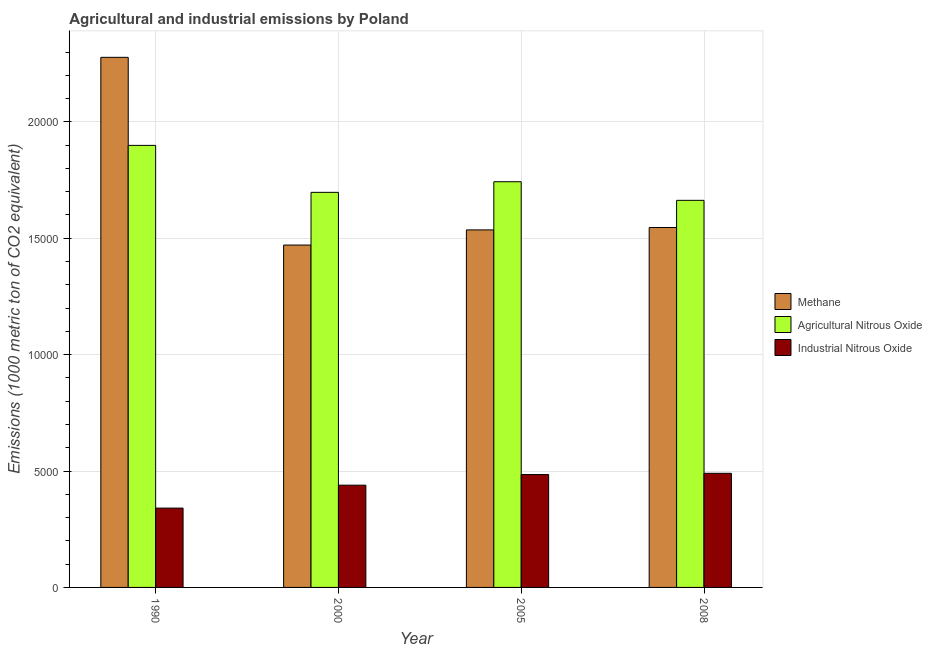How many different coloured bars are there?
Give a very brief answer. 3. How many groups of bars are there?
Your answer should be compact. 4. Are the number of bars on each tick of the X-axis equal?
Your answer should be very brief. Yes. How many bars are there on the 4th tick from the left?
Ensure brevity in your answer.  3. What is the amount of agricultural nitrous oxide emissions in 2008?
Offer a terse response. 1.66e+04. Across all years, what is the maximum amount of methane emissions?
Offer a terse response. 2.28e+04. Across all years, what is the minimum amount of industrial nitrous oxide emissions?
Provide a short and direct response. 3408.2. What is the total amount of agricultural nitrous oxide emissions in the graph?
Offer a very short reply. 7.00e+04. What is the difference between the amount of industrial nitrous oxide emissions in 1990 and that in 2005?
Provide a succinct answer. -1440.8. What is the difference between the amount of industrial nitrous oxide emissions in 2000 and the amount of methane emissions in 1990?
Your answer should be very brief. 984.3. What is the average amount of industrial nitrous oxide emissions per year?
Your response must be concise. 4388.1. In how many years, is the amount of industrial nitrous oxide emissions greater than 14000 metric ton?
Make the answer very short. 0. What is the ratio of the amount of industrial nitrous oxide emissions in 1990 to that in 2000?
Your response must be concise. 0.78. Is the amount of industrial nitrous oxide emissions in 2000 less than that in 2008?
Offer a very short reply. Yes. What is the difference between the highest and the second highest amount of industrial nitrous oxide emissions?
Offer a very short reply. 53.7. What is the difference between the highest and the lowest amount of industrial nitrous oxide emissions?
Your answer should be compact. 1494.5. Is the sum of the amount of industrial nitrous oxide emissions in 1990 and 2005 greater than the maximum amount of agricultural nitrous oxide emissions across all years?
Provide a short and direct response. Yes. What does the 3rd bar from the left in 2000 represents?
Provide a short and direct response. Industrial Nitrous Oxide. What does the 2nd bar from the right in 2000 represents?
Your response must be concise. Agricultural Nitrous Oxide. Is it the case that in every year, the sum of the amount of methane emissions and amount of agricultural nitrous oxide emissions is greater than the amount of industrial nitrous oxide emissions?
Your answer should be compact. Yes. How many bars are there?
Keep it short and to the point. 12. How many years are there in the graph?
Provide a succinct answer. 4. Are the values on the major ticks of Y-axis written in scientific E-notation?
Ensure brevity in your answer.  No. How many legend labels are there?
Keep it short and to the point. 3. What is the title of the graph?
Make the answer very short. Agricultural and industrial emissions by Poland. Does "Natural Gas" appear as one of the legend labels in the graph?
Keep it short and to the point. No. What is the label or title of the X-axis?
Ensure brevity in your answer.  Year. What is the label or title of the Y-axis?
Offer a terse response. Emissions (1000 metric ton of CO2 equivalent). What is the Emissions (1000 metric ton of CO2 equivalent) in Methane in 1990?
Your response must be concise. 2.28e+04. What is the Emissions (1000 metric ton of CO2 equivalent) in Agricultural Nitrous Oxide in 1990?
Provide a short and direct response. 1.90e+04. What is the Emissions (1000 metric ton of CO2 equivalent) of Industrial Nitrous Oxide in 1990?
Keep it short and to the point. 3408.2. What is the Emissions (1000 metric ton of CO2 equivalent) in Methane in 2000?
Your answer should be compact. 1.47e+04. What is the Emissions (1000 metric ton of CO2 equivalent) in Agricultural Nitrous Oxide in 2000?
Offer a terse response. 1.70e+04. What is the Emissions (1000 metric ton of CO2 equivalent) in Industrial Nitrous Oxide in 2000?
Your response must be concise. 4392.5. What is the Emissions (1000 metric ton of CO2 equivalent) of Methane in 2005?
Your answer should be compact. 1.54e+04. What is the Emissions (1000 metric ton of CO2 equivalent) in Agricultural Nitrous Oxide in 2005?
Give a very brief answer. 1.74e+04. What is the Emissions (1000 metric ton of CO2 equivalent) of Industrial Nitrous Oxide in 2005?
Ensure brevity in your answer.  4849. What is the Emissions (1000 metric ton of CO2 equivalent) of Methane in 2008?
Provide a short and direct response. 1.55e+04. What is the Emissions (1000 metric ton of CO2 equivalent) of Agricultural Nitrous Oxide in 2008?
Keep it short and to the point. 1.66e+04. What is the Emissions (1000 metric ton of CO2 equivalent) of Industrial Nitrous Oxide in 2008?
Your answer should be very brief. 4902.7. Across all years, what is the maximum Emissions (1000 metric ton of CO2 equivalent) in Methane?
Give a very brief answer. 2.28e+04. Across all years, what is the maximum Emissions (1000 metric ton of CO2 equivalent) of Agricultural Nitrous Oxide?
Make the answer very short. 1.90e+04. Across all years, what is the maximum Emissions (1000 metric ton of CO2 equivalent) of Industrial Nitrous Oxide?
Offer a very short reply. 4902.7. Across all years, what is the minimum Emissions (1000 metric ton of CO2 equivalent) of Methane?
Give a very brief answer. 1.47e+04. Across all years, what is the minimum Emissions (1000 metric ton of CO2 equivalent) in Agricultural Nitrous Oxide?
Offer a terse response. 1.66e+04. Across all years, what is the minimum Emissions (1000 metric ton of CO2 equivalent) in Industrial Nitrous Oxide?
Give a very brief answer. 3408.2. What is the total Emissions (1000 metric ton of CO2 equivalent) of Methane in the graph?
Provide a short and direct response. 6.83e+04. What is the total Emissions (1000 metric ton of CO2 equivalent) of Agricultural Nitrous Oxide in the graph?
Your answer should be compact. 7.00e+04. What is the total Emissions (1000 metric ton of CO2 equivalent) of Industrial Nitrous Oxide in the graph?
Your answer should be compact. 1.76e+04. What is the difference between the Emissions (1000 metric ton of CO2 equivalent) in Methane in 1990 and that in 2000?
Your answer should be compact. 8065. What is the difference between the Emissions (1000 metric ton of CO2 equivalent) of Agricultural Nitrous Oxide in 1990 and that in 2000?
Make the answer very short. 2018.2. What is the difference between the Emissions (1000 metric ton of CO2 equivalent) of Industrial Nitrous Oxide in 1990 and that in 2000?
Your answer should be compact. -984.3. What is the difference between the Emissions (1000 metric ton of CO2 equivalent) of Methane in 1990 and that in 2005?
Make the answer very short. 7413.7. What is the difference between the Emissions (1000 metric ton of CO2 equivalent) of Agricultural Nitrous Oxide in 1990 and that in 2005?
Keep it short and to the point. 1561.1. What is the difference between the Emissions (1000 metric ton of CO2 equivalent) of Industrial Nitrous Oxide in 1990 and that in 2005?
Make the answer very short. -1440.8. What is the difference between the Emissions (1000 metric ton of CO2 equivalent) in Methane in 1990 and that in 2008?
Keep it short and to the point. 7311.1. What is the difference between the Emissions (1000 metric ton of CO2 equivalent) in Agricultural Nitrous Oxide in 1990 and that in 2008?
Provide a short and direct response. 2360.6. What is the difference between the Emissions (1000 metric ton of CO2 equivalent) in Industrial Nitrous Oxide in 1990 and that in 2008?
Your response must be concise. -1494.5. What is the difference between the Emissions (1000 metric ton of CO2 equivalent) in Methane in 2000 and that in 2005?
Ensure brevity in your answer.  -651.3. What is the difference between the Emissions (1000 metric ton of CO2 equivalent) of Agricultural Nitrous Oxide in 2000 and that in 2005?
Your answer should be compact. -457.1. What is the difference between the Emissions (1000 metric ton of CO2 equivalent) in Industrial Nitrous Oxide in 2000 and that in 2005?
Provide a succinct answer. -456.5. What is the difference between the Emissions (1000 metric ton of CO2 equivalent) in Methane in 2000 and that in 2008?
Offer a very short reply. -753.9. What is the difference between the Emissions (1000 metric ton of CO2 equivalent) in Agricultural Nitrous Oxide in 2000 and that in 2008?
Provide a short and direct response. 342.4. What is the difference between the Emissions (1000 metric ton of CO2 equivalent) in Industrial Nitrous Oxide in 2000 and that in 2008?
Offer a very short reply. -510.2. What is the difference between the Emissions (1000 metric ton of CO2 equivalent) of Methane in 2005 and that in 2008?
Provide a succinct answer. -102.6. What is the difference between the Emissions (1000 metric ton of CO2 equivalent) of Agricultural Nitrous Oxide in 2005 and that in 2008?
Your response must be concise. 799.5. What is the difference between the Emissions (1000 metric ton of CO2 equivalent) in Industrial Nitrous Oxide in 2005 and that in 2008?
Your response must be concise. -53.7. What is the difference between the Emissions (1000 metric ton of CO2 equivalent) of Methane in 1990 and the Emissions (1000 metric ton of CO2 equivalent) of Agricultural Nitrous Oxide in 2000?
Your answer should be compact. 5801. What is the difference between the Emissions (1000 metric ton of CO2 equivalent) of Methane in 1990 and the Emissions (1000 metric ton of CO2 equivalent) of Industrial Nitrous Oxide in 2000?
Your answer should be compact. 1.84e+04. What is the difference between the Emissions (1000 metric ton of CO2 equivalent) in Agricultural Nitrous Oxide in 1990 and the Emissions (1000 metric ton of CO2 equivalent) in Industrial Nitrous Oxide in 2000?
Ensure brevity in your answer.  1.46e+04. What is the difference between the Emissions (1000 metric ton of CO2 equivalent) of Methane in 1990 and the Emissions (1000 metric ton of CO2 equivalent) of Agricultural Nitrous Oxide in 2005?
Give a very brief answer. 5343.9. What is the difference between the Emissions (1000 metric ton of CO2 equivalent) of Methane in 1990 and the Emissions (1000 metric ton of CO2 equivalent) of Industrial Nitrous Oxide in 2005?
Make the answer very short. 1.79e+04. What is the difference between the Emissions (1000 metric ton of CO2 equivalent) in Agricultural Nitrous Oxide in 1990 and the Emissions (1000 metric ton of CO2 equivalent) in Industrial Nitrous Oxide in 2005?
Offer a very short reply. 1.41e+04. What is the difference between the Emissions (1000 metric ton of CO2 equivalent) of Methane in 1990 and the Emissions (1000 metric ton of CO2 equivalent) of Agricultural Nitrous Oxide in 2008?
Make the answer very short. 6143.4. What is the difference between the Emissions (1000 metric ton of CO2 equivalent) in Methane in 1990 and the Emissions (1000 metric ton of CO2 equivalent) in Industrial Nitrous Oxide in 2008?
Ensure brevity in your answer.  1.79e+04. What is the difference between the Emissions (1000 metric ton of CO2 equivalent) of Agricultural Nitrous Oxide in 1990 and the Emissions (1000 metric ton of CO2 equivalent) of Industrial Nitrous Oxide in 2008?
Give a very brief answer. 1.41e+04. What is the difference between the Emissions (1000 metric ton of CO2 equivalent) of Methane in 2000 and the Emissions (1000 metric ton of CO2 equivalent) of Agricultural Nitrous Oxide in 2005?
Provide a short and direct response. -2721.1. What is the difference between the Emissions (1000 metric ton of CO2 equivalent) of Methane in 2000 and the Emissions (1000 metric ton of CO2 equivalent) of Industrial Nitrous Oxide in 2005?
Offer a very short reply. 9859.5. What is the difference between the Emissions (1000 metric ton of CO2 equivalent) of Agricultural Nitrous Oxide in 2000 and the Emissions (1000 metric ton of CO2 equivalent) of Industrial Nitrous Oxide in 2005?
Ensure brevity in your answer.  1.21e+04. What is the difference between the Emissions (1000 metric ton of CO2 equivalent) in Methane in 2000 and the Emissions (1000 metric ton of CO2 equivalent) in Agricultural Nitrous Oxide in 2008?
Your response must be concise. -1921.6. What is the difference between the Emissions (1000 metric ton of CO2 equivalent) of Methane in 2000 and the Emissions (1000 metric ton of CO2 equivalent) of Industrial Nitrous Oxide in 2008?
Your response must be concise. 9805.8. What is the difference between the Emissions (1000 metric ton of CO2 equivalent) in Agricultural Nitrous Oxide in 2000 and the Emissions (1000 metric ton of CO2 equivalent) in Industrial Nitrous Oxide in 2008?
Offer a terse response. 1.21e+04. What is the difference between the Emissions (1000 metric ton of CO2 equivalent) in Methane in 2005 and the Emissions (1000 metric ton of CO2 equivalent) in Agricultural Nitrous Oxide in 2008?
Ensure brevity in your answer.  -1270.3. What is the difference between the Emissions (1000 metric ton of CO2 equivalent) of Methane in 2005 and the Emissions (1000 metric ton of CO2 equivalent) of Industrial Nitrous Oxide in 2008?
Keep it short and to the point. 1.05e+04. What is the difference between the Emissions (1000 metric ton of CO2 equivalent) of Agricultural Nitrous Oxide in 2005 and the Emissions (1000 metric ton of CO2 equivalent) of Industrial Nitrous Oxide in 2008?
Ensure brevity in your answer.  1.25e+04. What is the average Emissions (1000 metric ton of CO2 equivalent) of Methane per year?
Keep it short and to the point. 1.71e+04. What is the average Emissions (1000 metric ton of CO2 equivalent) of Agricultural Nitrous Oxide per year?
Offer a very short reply. 1.75e+04. What is the average Emissions (1000 metric ton of CO2 equivalent) in Industrial Nitrous Oxide per year?
Provide a succinct answer. 4388.1. In the year 1990, what is the difference between the Emissions (1000 metric ton of CO2 equivalent) of Methane and Emissions (1000 metric ton of CO2 equivalent) of Agricultural Nitrous Oxide?
Ensure brevity in your answer.  3782.8. In the year 1990, what is the difference between the Emissions (1000 metric ton of CO2 equivalent) of Methane and Emissions (1000 metric ton of CO2 equivalent) of Industrial Nitrous Oxide?
Make the answer very short. 1.94e+04. In the year 1990, what is the difference between the Emissions (1000 metric ton of CO2 equivalent) in Agricultural Nitrous Oxide and Emissions (1000 metric ton of CO2 equivalent) in Industrial Nitrous Oxide?
Give a very brief answer. 1.56e+04. In the year 2000, what is the difference between the Emissions (1000 metric ton of CO2 equivalent) of Methane and Emissions (1000 metric ton of CO2 equivalent) of Agricultural Nitrous Oxide?
Keep it short and to the point. -2264. In the year 2000, what is the difference between the Emissions (1000 metric ton of CO2 equivalent) in Methane and Emissions (1000 metric ton of CO2 equivalent) in Industrial Nitrous Oxide?
Offer a terse response. 1.03e+04. In the year 2000, what is the difference between the Emissions (1000 metric ton of CO2 equivalent) of Agricultural Nitrous Oxide and Emissions (1000 metric ton of CO2 equivalent) of Industrial Nitrous Oxide?
Offer a very short reply. 1.26e+04. In the year 2005, what is the difference between the Emissions (1000 metric ton of CO2 equivalent) in Methane and Emissions (1000 metric ton of CO2 equivalent) in Agricultural Nitrous Oxide?
Your response must be concise. -2069.8. In the year 2005, what is the difference between the Emissions (1000 metric ton of CO2 equivalent) in Methane and Emissions (1000 metric ton of CO2 equivalent) in Industrial Nitrous Oxide?
Offer a terse response. 1.05e+04. In the year 2005, what is the difference between the Emissions (1000 metric ton of CO2 equivalent) in Agricultural Nitrous Oxide and Emissions (1000 metric ton of CO2 equivalent) in Industrial Nitrous Oxide?
Offer a very short reply. 1.26e+04. In the year 2008, what is the difference between the Emissions (1000 metric ton of CO2 equivalent) of Methane and Emissions (1000 metric ton of CO2 equivalent) of Agricultural Nitrous Oxide?
Offer a terse response. -1167.7. In the year 2008, what is the difference between the Emissions (1000 metric ton of CO2 equivalent) of Methane and Emissions (1000 metric ton of CO2 equivalent) of Industrial Nitrous Oxide?
Ensure brevity in your answer.  1.06e+04. In the year 2008, what is the difference between the Emissions (1000 metric ton of CO2 equivalent) of Agricultural Nitrous Oxide and Emissions (1000 metric ton of CO2 equivalent) of Industrial Nitrous Oxide?
Provide a short and direct response. 1.17e+04. What is the ratio of the Emissions (1000 metric ton of CO2 equivalent) in Methane in 1990 to that in 2000?
Offer a terse response. 1.55. What is the ratio of the Emissions (1000 metric ton of CO2 equivalent) in Agricultural Nitrous Oxide in 1990 to that in 2000?
Make the answer very short. 1.12. What is the ratio of the Emissions (1000 metric ton of CO2 equivalent) in Industrial Nitrous Oxide in 1990 to that in 2000?
Offer a very short reply. 0.78. What is the ratio of the Emissions (1000 metric ton of CO2 equivalent) of Methane in 1990 to that in 2005?
Ensure brevity in your answer.  1.48. What is the ratio of the Emissions (1000 metric ton of CO2 equivalent) in Agricultural Nitrous Oxide in 1990 to that in 2005?
Provide a succinct answer. 1.09. What is the ratio of the Emissions (1000 metric ton of CO2 equivalent) in Industrial Nitrous Oxide in 1990 to that in 2005?
Make the answer very short. 0.7. What is the ratio of the Emissions (1000 metric ton of CO2 equivalent) in Methane in 1990 to that in 2008?
Your answer should be compact. 1.47. What is the ratio of the Emissions (1000 metric ton of CO2 equivalent) in Agricultural Nitrous Oxide in 1990 to that in 2008?
Your answer should be very brief. 1.14. What is the ratio of the Emissions (1000 metric ton of CO2 equivalent) of Industrial Nitrous Oxide in 1990 to that in 2008?
Keep it short and to the point. 0.7. What is the ratio of the Emissions (1000 metric ton of CO2 equivalent) of Methane in 2000 to that in 2005?
Give a very brief answer. 0.96. What is the ratio of the Emissions (1000 metric ton of CO2 equivalent) of Agricultural Nitrous Oxide in 2000 to that in 2005?
Offer a terse response. 0.97. What is the ratio of the Emissions (1000 metric ton of CO2 equivalent) of Industrial Nitrous Oxide in 2000 to that in 2005?
Provide a succinct answer. 0.91. What is the ratio of the Emissions (1000 metric ton of CO2 equivalent) of Methane in 2000 to that in 2008?
Offer a very short reply. 0.95. What is the ratio of the Emissions (1000 metric ton of CO2 equivalent) of Agricultural Nitrous Oxide in 2000 to that in 2008?
Ensure brevity in your answer.  1.02. What is the ratio of the Emissions (1000 metric ton of CO2 equivalent) of Industrial Nitrous Oxide in 2000 to that in 2008?
Provide a short and direct response. 0.9. What is the ratio of the Emissions (1000 metric ton of CO2 equivalent) in Methane in 2005 to that in 2008?
Offer a terse response. 0.99. What is the ratio of the Emissions (1000 metric ton of CO2 equivalent) in Agricultural Nitrous Oxide in 2005 to that in 2008?
Make the answer very short. 1.05. What is the ratio of the Emissions (1000 metric ton of CO2 equivalent) in Industrial Nitrous Oxide in 2005 to that in 2008?
Ensure brevity in your answer.  0.99. What is the difference between the highest and the second highest Emissions (1000 metric ton of CO2 equivalent) in Methane?
Your answer should be compact. 7311.1. What is the difference between the highest and the second highest Emissions (1000 metric ton of CO2 equivalent) of Agricultural Nitrous Oxide?
Your answer should be compact. 1561.1. What is the difference between the highest and the second highest Emissions (1000 metric ton of CO2 equivalent) of Industrial Nitrous Oxide?
Ensure brevity in your answer.  53.7. What is the difference between the highest and the lowest Emissions (1000 metric ton of CO2 equivalent) of Methane?
Make the answer very short. 8065. What is the difference between the highest and the lowest Emissions (1000 metric ton of CO2 equivalent) in Agricultural Nitrous Oxide?
Offer a terse response. 2360.6. What is the difference between the highest and the lowest Emissions (1000 metric ton of CO2 equivalent) of Industrial Nitrous Oxide?
Your response must be concise. 1494.5. 